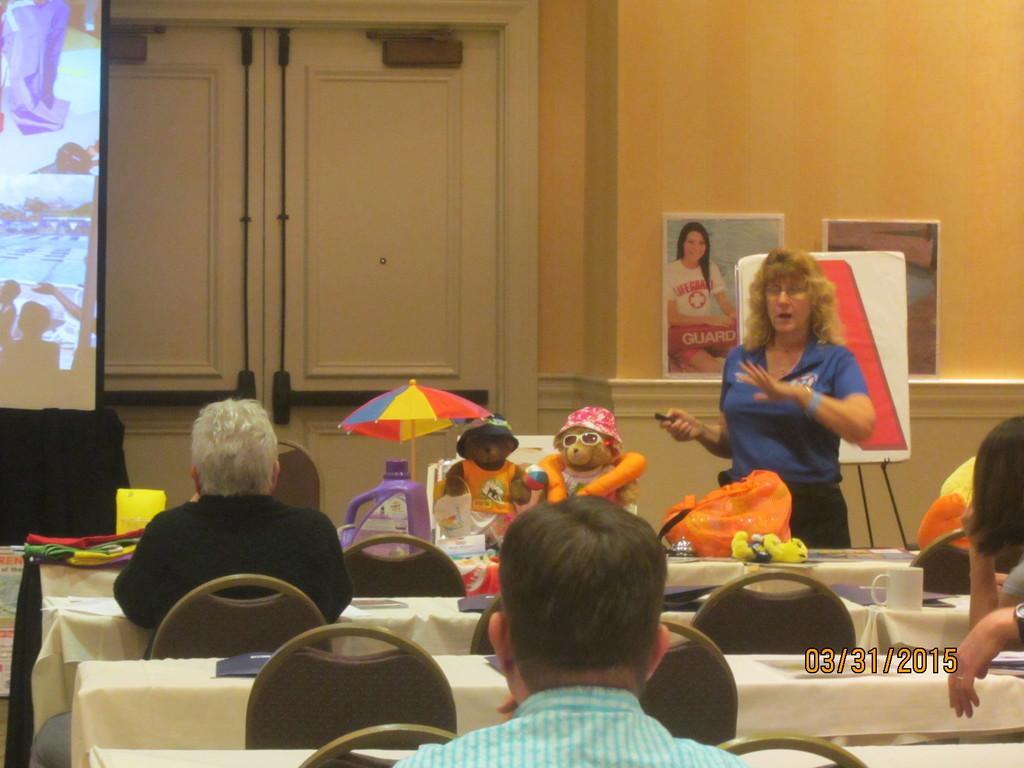How would you summarize this image in a sentence or two? In this picture we can see some people are sitting on chairs in front of tables, on the left side there is a screen, on the right side we can see a woman is standing, there is an umbrella, dolls and a bag present in the middle, in the background there is a wall, we can see two posters on the wall, we can also see double door in the background. 